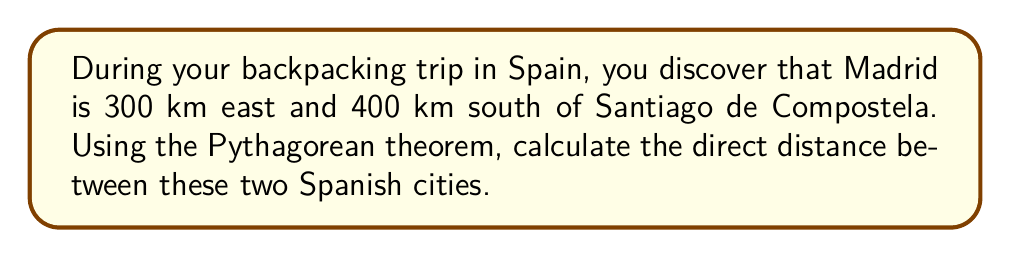Can you answer this question? Let's approach this step-by-step using the Pythagorean theorem:

1. Visualize the problem:
   [asy]
   import geometry;
   
   pair A = (0,0);
   pair B = (3,0);
   pair C = (3,-4);
   
   draw(A--B--C--A);
   
   label("Santiago de Compostela", A, NW);
   label("Madrid", C, SE);
   label("300 km", (A+B)/2, N);
   label("400 km", (B+C)/2, E);
   label("?", (A+C)/2, SW);
   [/asy]

2. Identify the known values:
   - East distance (a) = 300 km
   - South distance (b) = 400 km
   - Direct distance (c) = unknown

3. Apply the Pythagorean theorem: $c^2 = a^2 + b^2$

4. Substitute the known values:
   $c^2 = 300^2 + 400^2$

5. Calculate the squares:
   $c^2 = 90,000 + 160,000 = 250,000$

6. Take the square root of both sides:
   $c = \sqrt{250,000}$

7. Simplify:
   $c = 500$ km

Therefore, the direct distance between Santiago de Compostela and Madrid is 500 km.
Answer: 500 km 